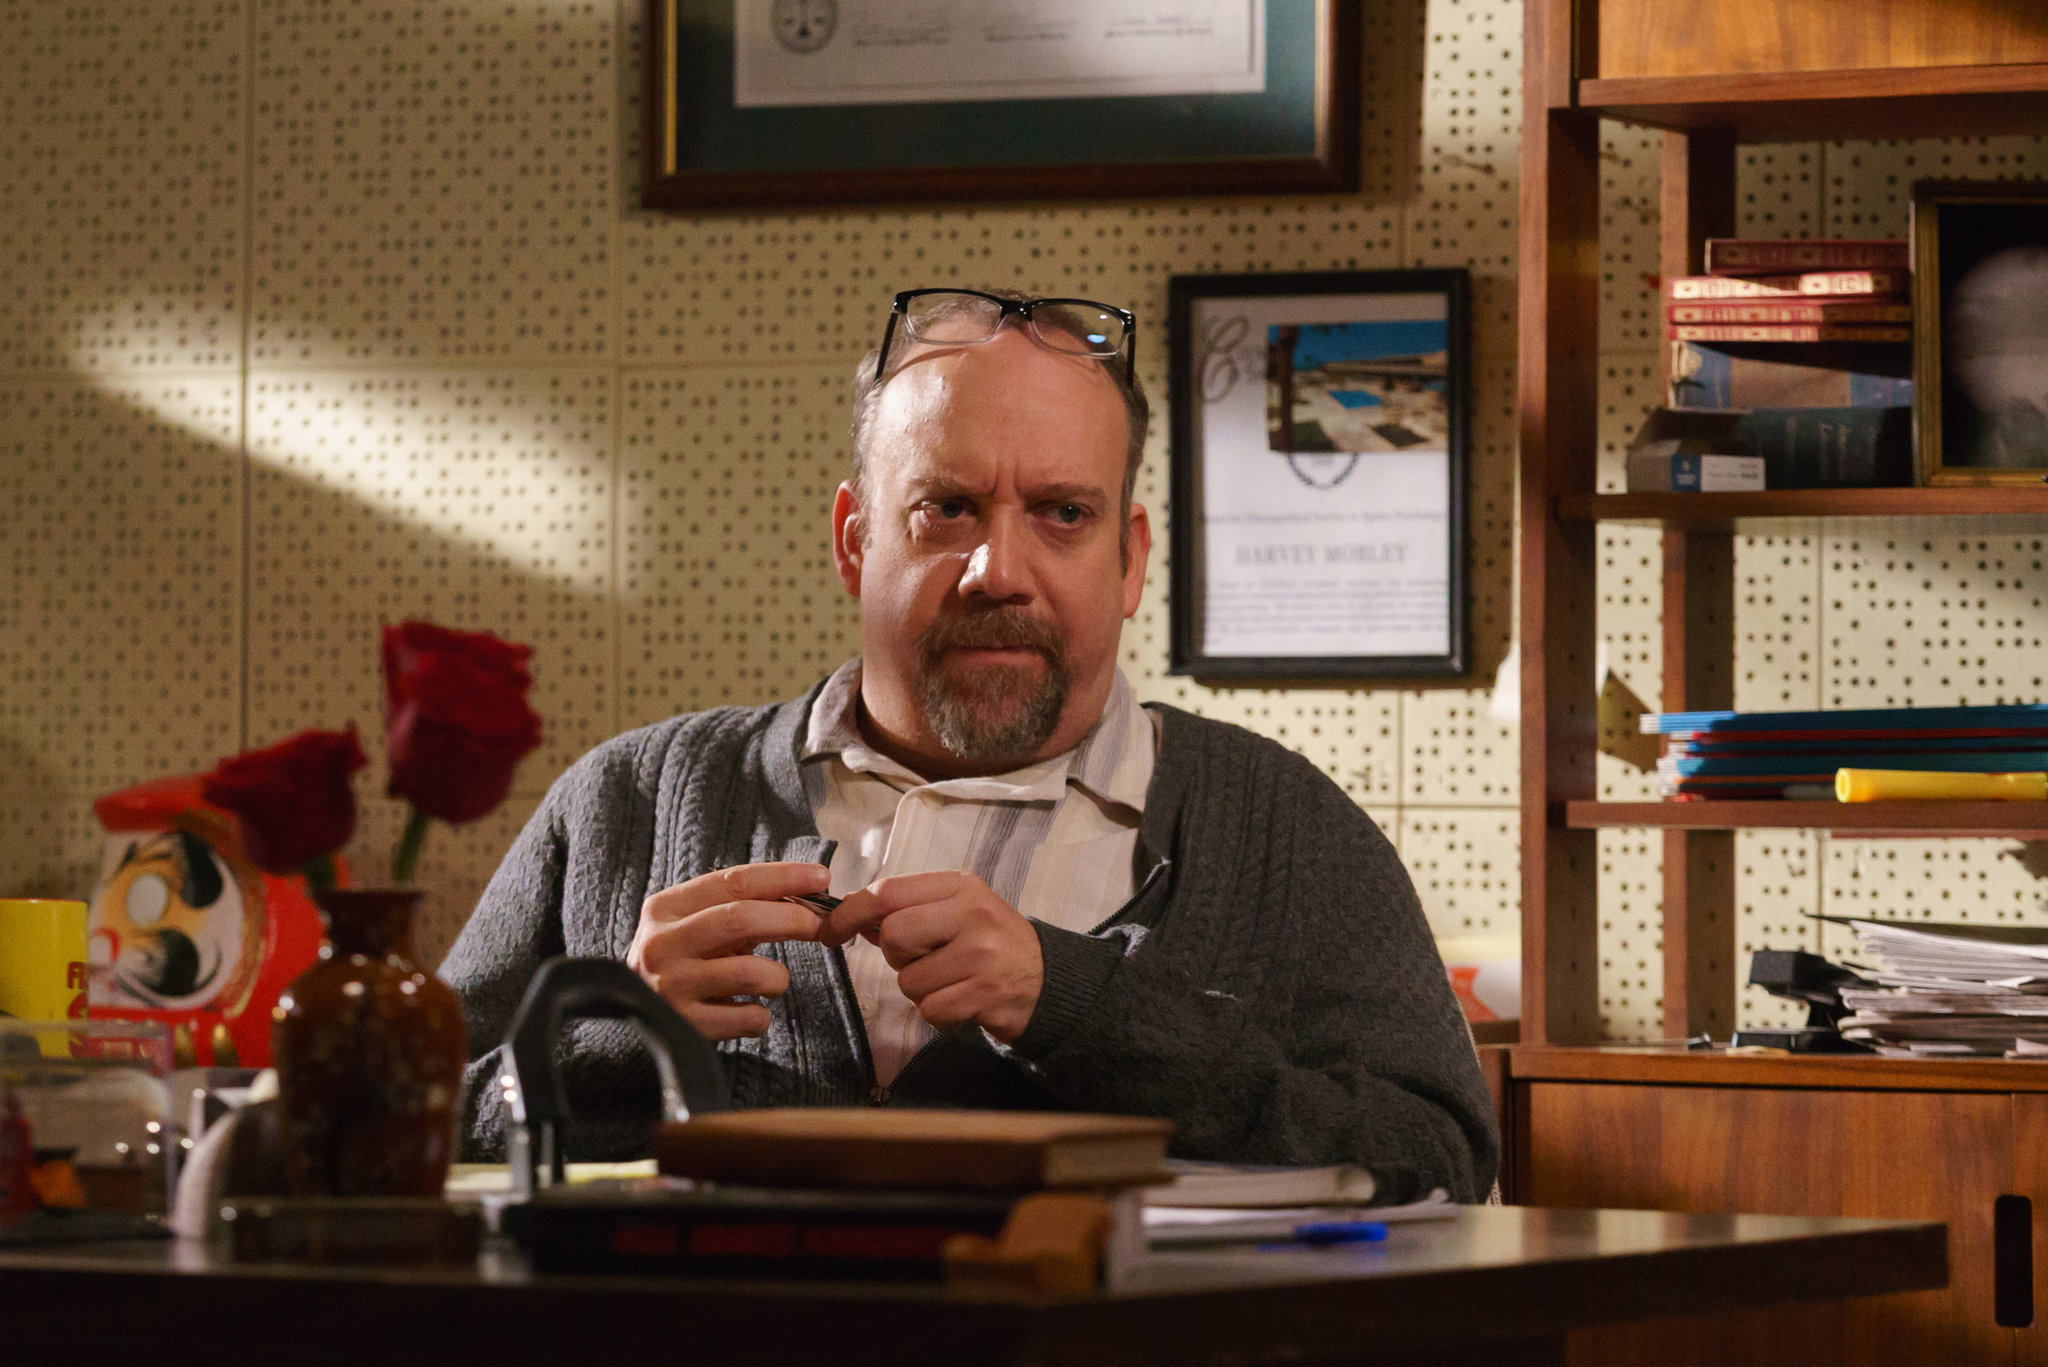Imagine if the office in the image could talk. What stories would it share about the man who works there? If the office in the image could talk, it would weave stories of perseverance, passion, and profound solitude. It would recount countless late nights spent beneath the warm glow of a desk lamp, with the man poring over ancient texts, lost in the pursuit of knowledge. The office would speak of moments of triumph when new discoveries were made, and the man's eyes lit up with excitement, his heart beating with the thrill of uncovering forgotten truths. It would also share tales of quieter, introspective times, when the man sat motionless, bathed in the morning light, contemplating the vastness of what he had learned and what still eluded him. The framed certificates and the cluttered bookshelf would serve as silent witnesses of his journey, bearing testimony to a life devoted to understanding the complexities of humanity. The office might even whisper about the occasional intrusions from the outside world, bringing unexpected challenges and mysteries, each adding another layer to the tapestry of the man's existence. 